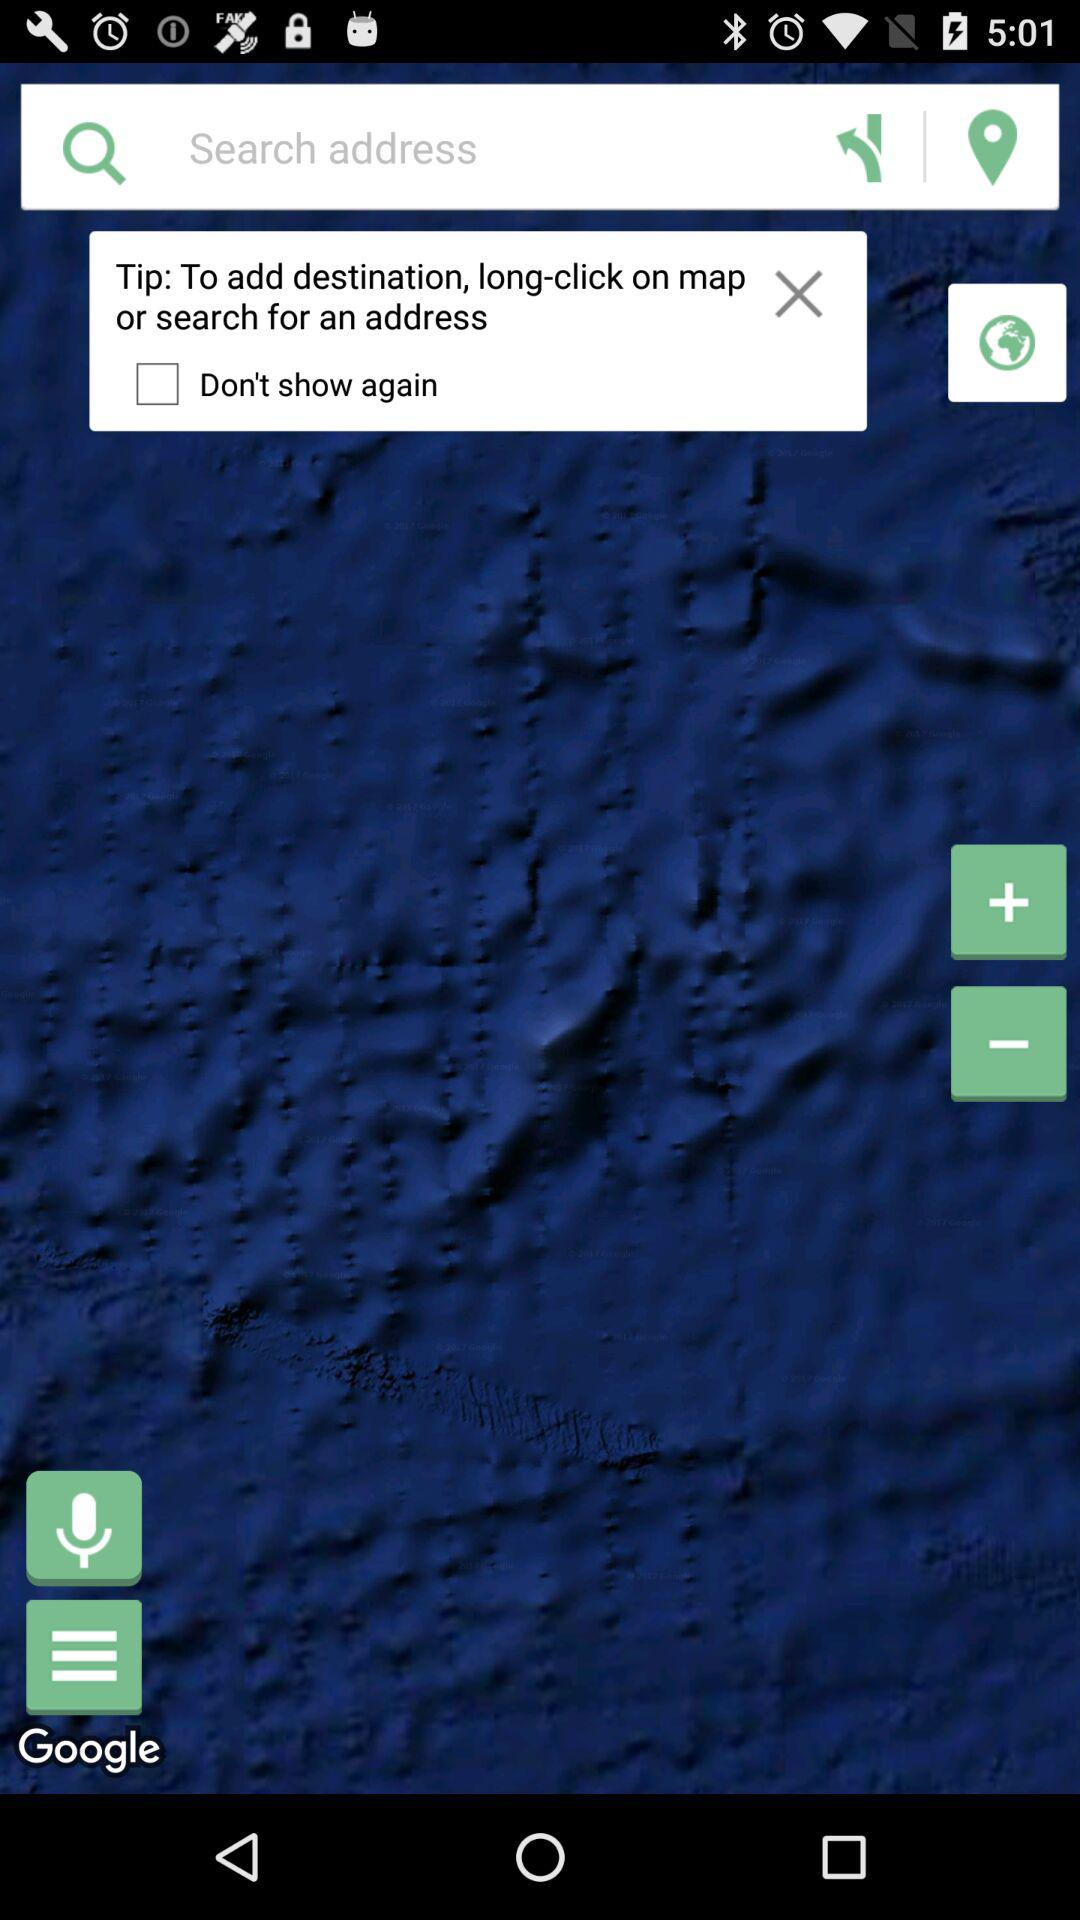What is the status of "Don't show again"? The status of "Don't show again" is "off". 